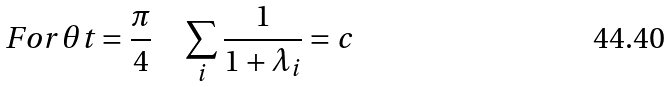<formula> <loc_0><loc_0><loc_500><loc_500>F o r \, \theta t = \frac { \pi } { 4 } \quad \sum _ { i } \frac { 1 } { 1 + \lambda _ { i } } = c</formula> 